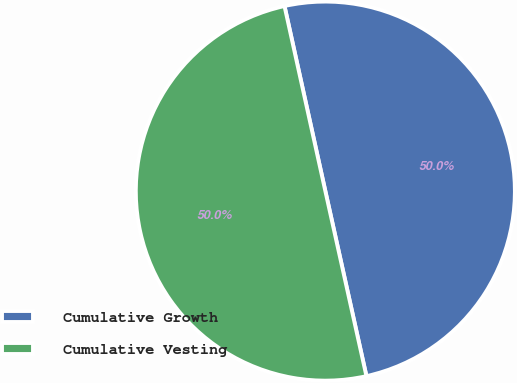Convert chart to OTSL. <chart><loc_0><loc_0><loc_500><loc_500><pie_chart><fcel>Cumulative Growth<fcel>Cumulative Vesting<nl><fcel>49.98%<fcel>50.02%<nl></chart> 